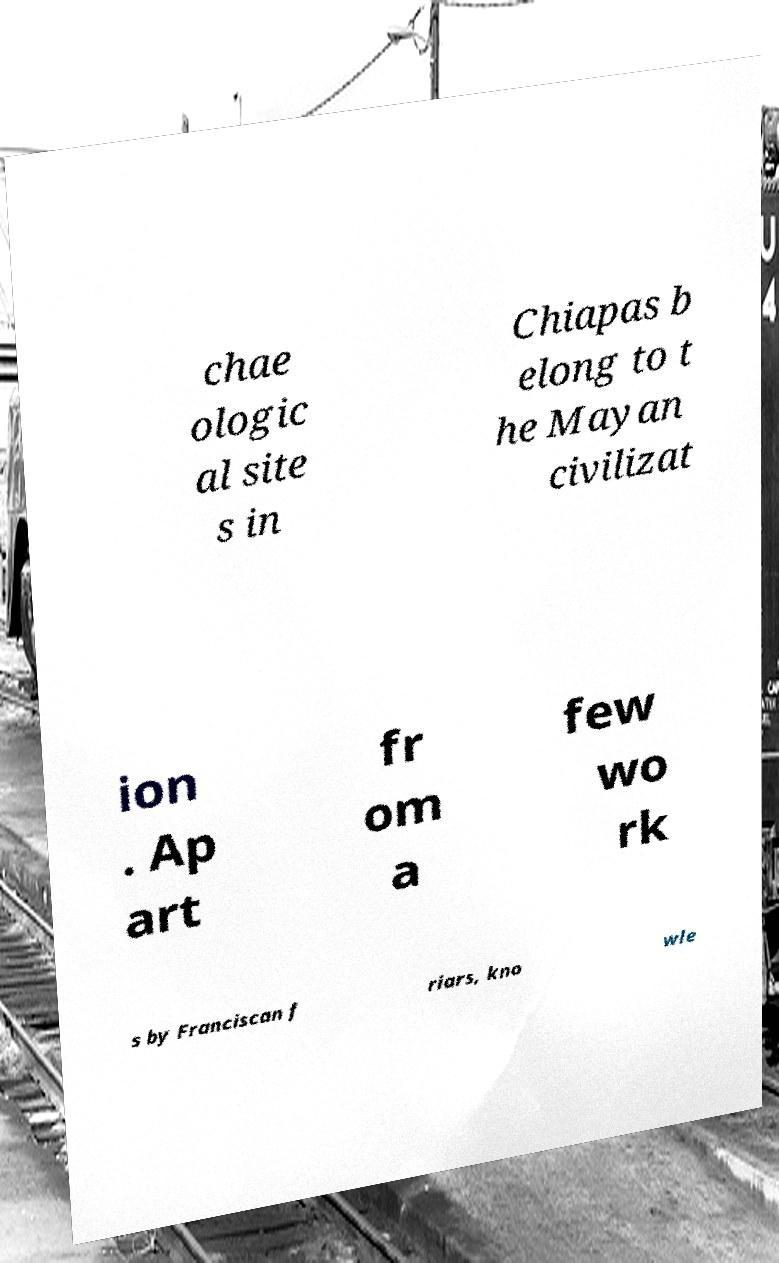There's text embedded in this image that I need extracted. Can you transcribe it verbatim? chae ologic al site s in Chiapas b elong to t he Mayan civilizat ion . Ap art fr om a few wo rk s by Franciscan f riars, kno wle 